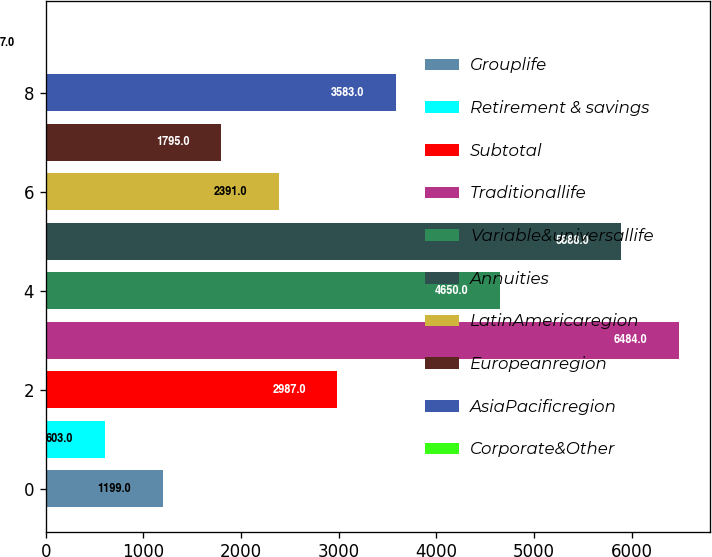<chart> <loc_0><loc_0><loc_500><loc_500><bar_chart><fcel>Grouplife<fcel>Retirement & savings<fcel>Subtotal<fcel>Traditionallife<fcel>Variable&universallife<fcel>Annuities<fcel>LatinAmericaregion<fcel>Europeanregion<fcel>AsiaPacificregion<fcel>Corporate&Other<nl><fcel>1199<fcel>603<fcel>2987<fcel>6484<fcel>4650<fcel>5888<fcel>2391<fcel>1795<fcel>3583<fcel>7<nl></chart> 